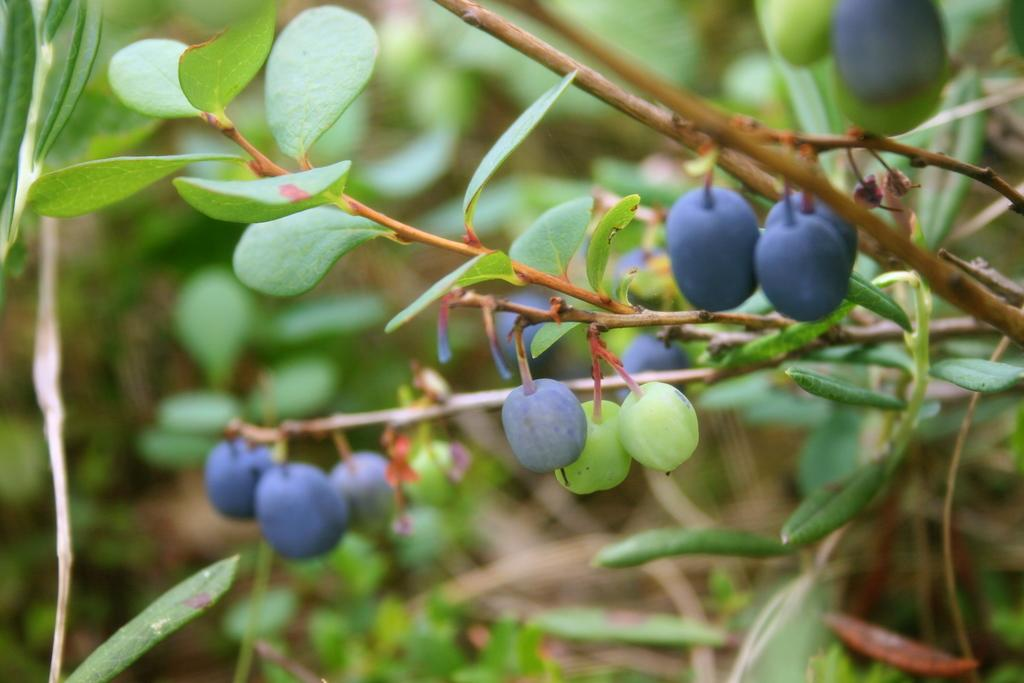What type of fruit is attached to a stem in the image? There are berries attached to a stem in the image. What else can be seen in the image besides the berries? There are leaves in the image. Can you describe the background of the image? The backdrop of the image is blurred. What type of bread is being eaten by the bear in the image? There is no bread or bear present in the image. 